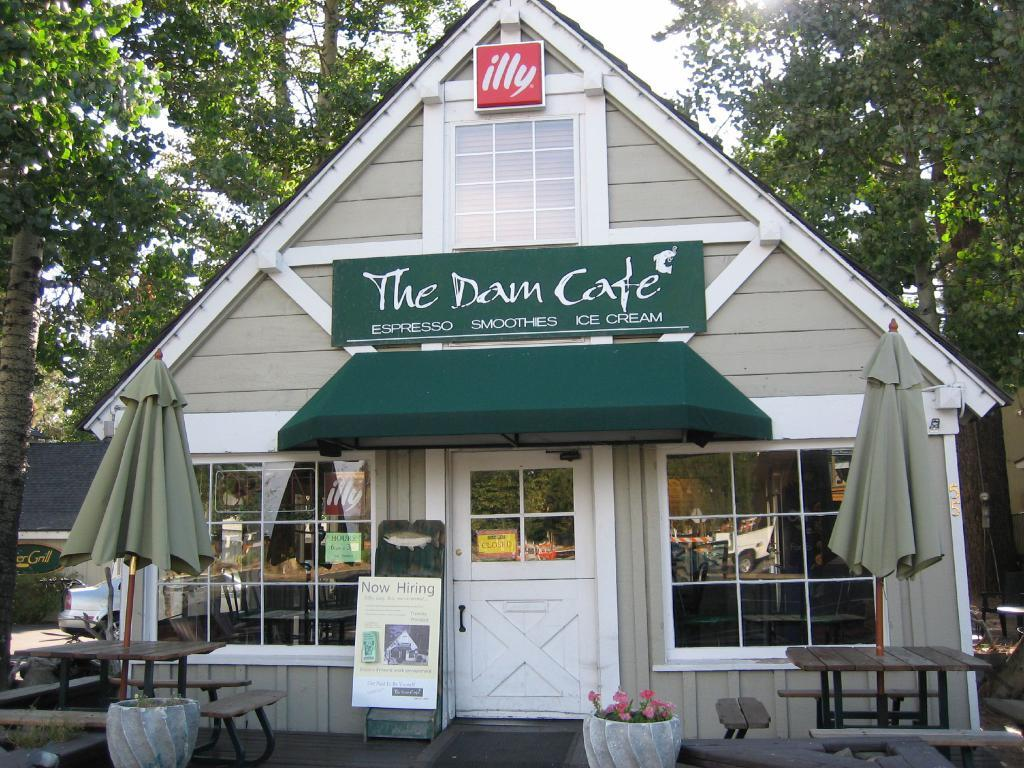What is the main structure in the center of the image? There is a shed in the center of the image. What type of objects are present for shade in the image? There are parasols in the image. What type of seating is available at the bottom of the image? There are benches at the bottom of the image. What type of decorative items can be seen in the image? There are flower pots in the image. What can be seen in the background of the image? There are trees and sky visible in the background of the image. What type of sign or notice is present in the image? There is a board in the image. How many students are expected to join the class in the image? There is no class or students present in the image. What type of clothing is being dropped by the person in the image? There is no person or clothing being dropped in the image. 